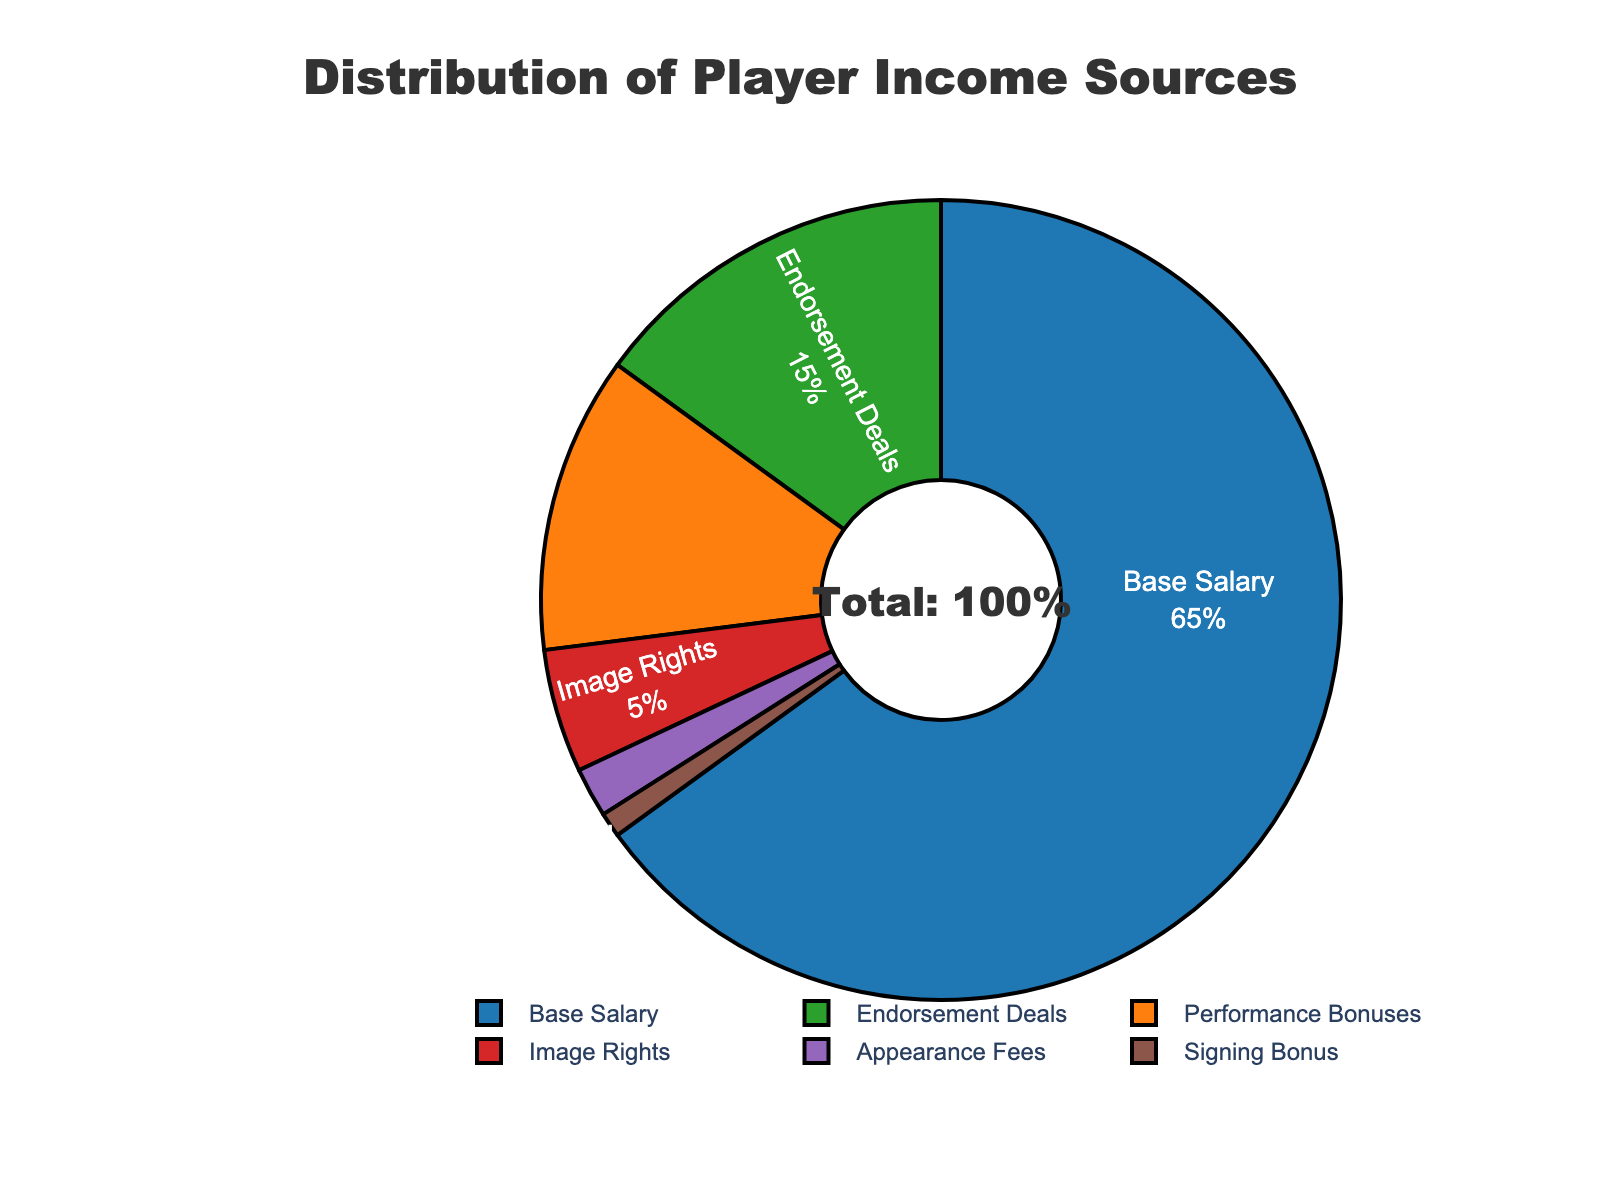What is the largest source of player income? The pie chart shows the distribution of income sources, and the largest segment by percentage is "Base Salary" at 65%.
Answer: Base Salary How much more is the percentage of income from Endorsement Deals compared to Appearance Fees? The percentage for Endorsement Deals is 15%, and for Appearance Fees, it is 2%. The difference is 15% - 2% = 13%.
Answer: 13% Which two sources combined make up less than 10% of player income? Both Signing Bonus (1%) and Appearance Fees (2%) together contribute 3%, which is less than 10%.
Answer: Signing Bonus and Appearance Fees How does Performance Bonuses compare with Endorsement Deals in terms of percentage? Performance Bonuses account for 12% of the income, while Endorsement Deals account for 15%. Endorsement Deals have a higher percentage.
Answer: Endorsement Deals are higher If you combine the percentages of Performance Bonuses and Image Rights, what is their total contribution to income? Performance Bonuses contribute 12% and Image Rights 5%. Their combined contribution is 12% + 5% = 17%.
Answer: 17% What income source is represented by the smallest segment? The smallest segment in the pie chart is "Signing Bonus" at 1%.
Answer: Signing Bonus Which source of player income is represented by a segment with a purple color? The chart's color palette identifies "Image Rights" with the purple segment, and its percentage is 5%.
Answer: Image Rights How many income sources together make up exactly 30% of the player income? Adding up percentages: Endorsement Deals (15%) + Performance Bonuses (12%) = 27%. Including Image Rights (5%) and Signing Bonus (1%) gives a combined total of 33%. To get exactly 30%, you can consider Performance Bonuses (12%) + Image Rights (5%) + Appearance Fees (2%) = 19%. The combination of options does not sum up to exactly 30% but different combinations can be explored in steps.
Answer: No exact combination for exactly 30% What is the combined percentage of player income from sources not related to the base salary? Total player income is 100%. The base salary is 65%, so the combined percentage of other sources is 100% - 65% = 35%.
Answer: 35% If the appearance fee percentage doubled, what would the new total percentage for Appearance Fees be? If the Appearance Fees percentage doubled from 2%, the new percentage would be 2% * 2 = 4%.
Answer: 4% 